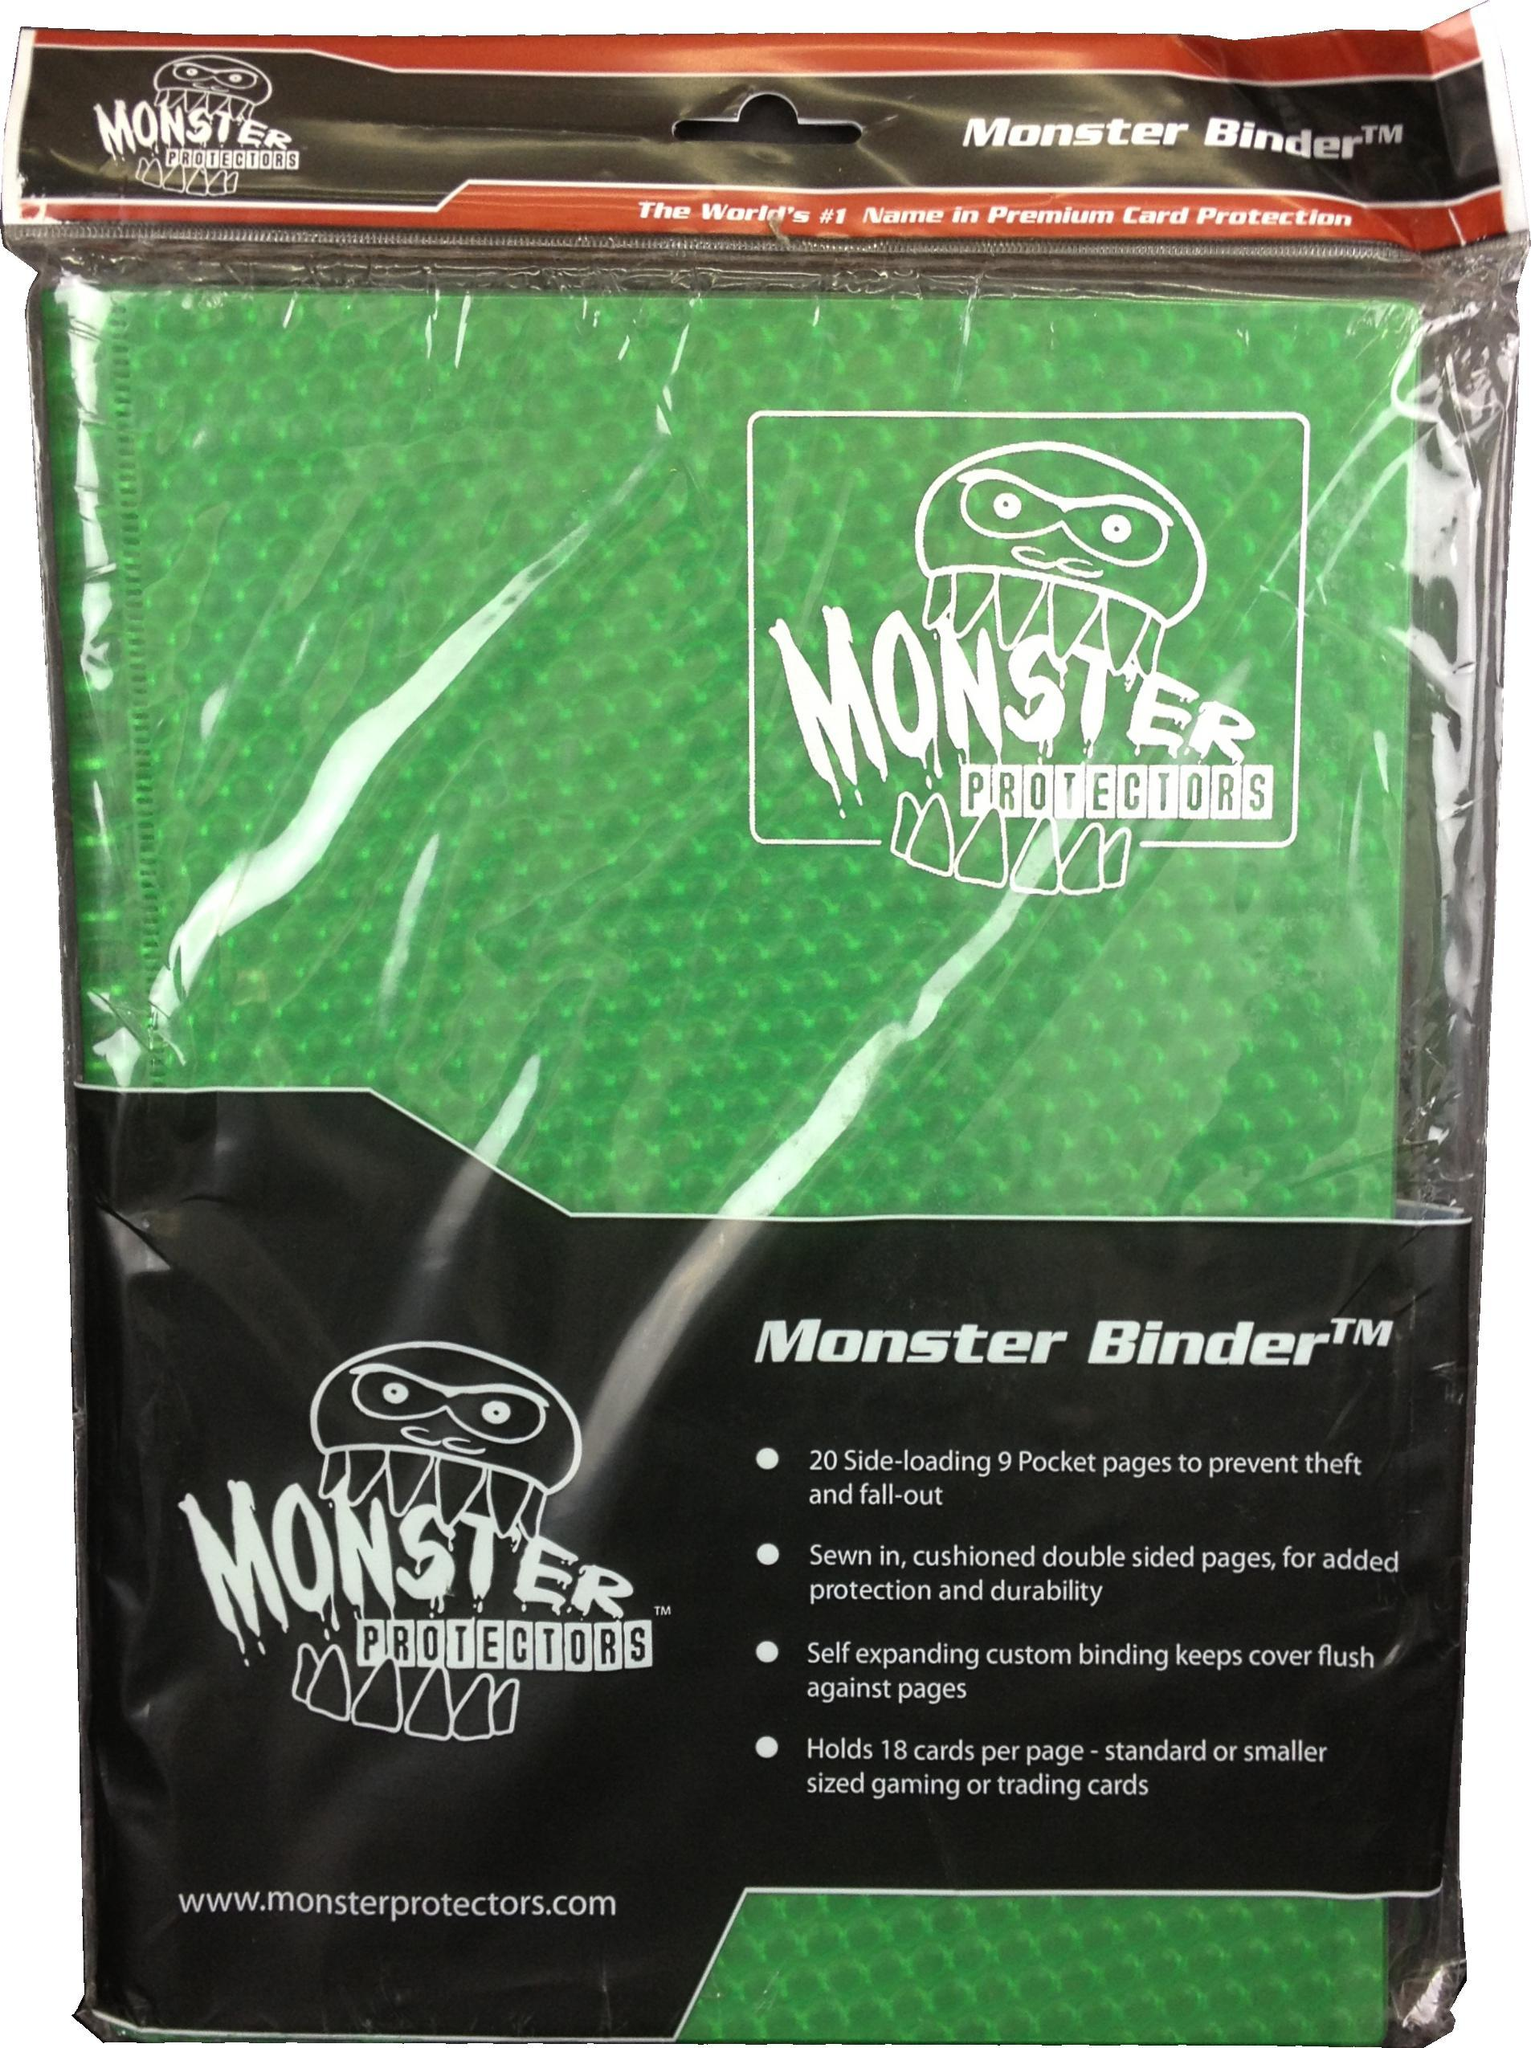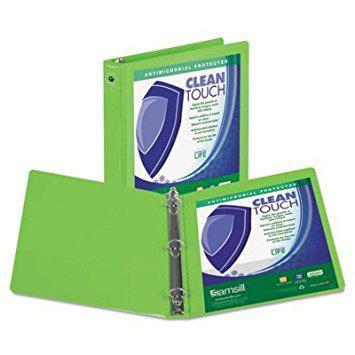The first image is the image on the left, the second image is the image on the right. Evaluate the accuracy of this statement regarding the images: "The right image shows two binders.". Is it true? Answer yes or no. Yes. 